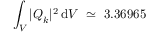<formula> <loc_0><loc_0><loc_500><loc_500>\int _ { V } | Q _ { k } | ^ { 2 } \, d V \simeq 3 . 3 6 9 6 5</formula> 